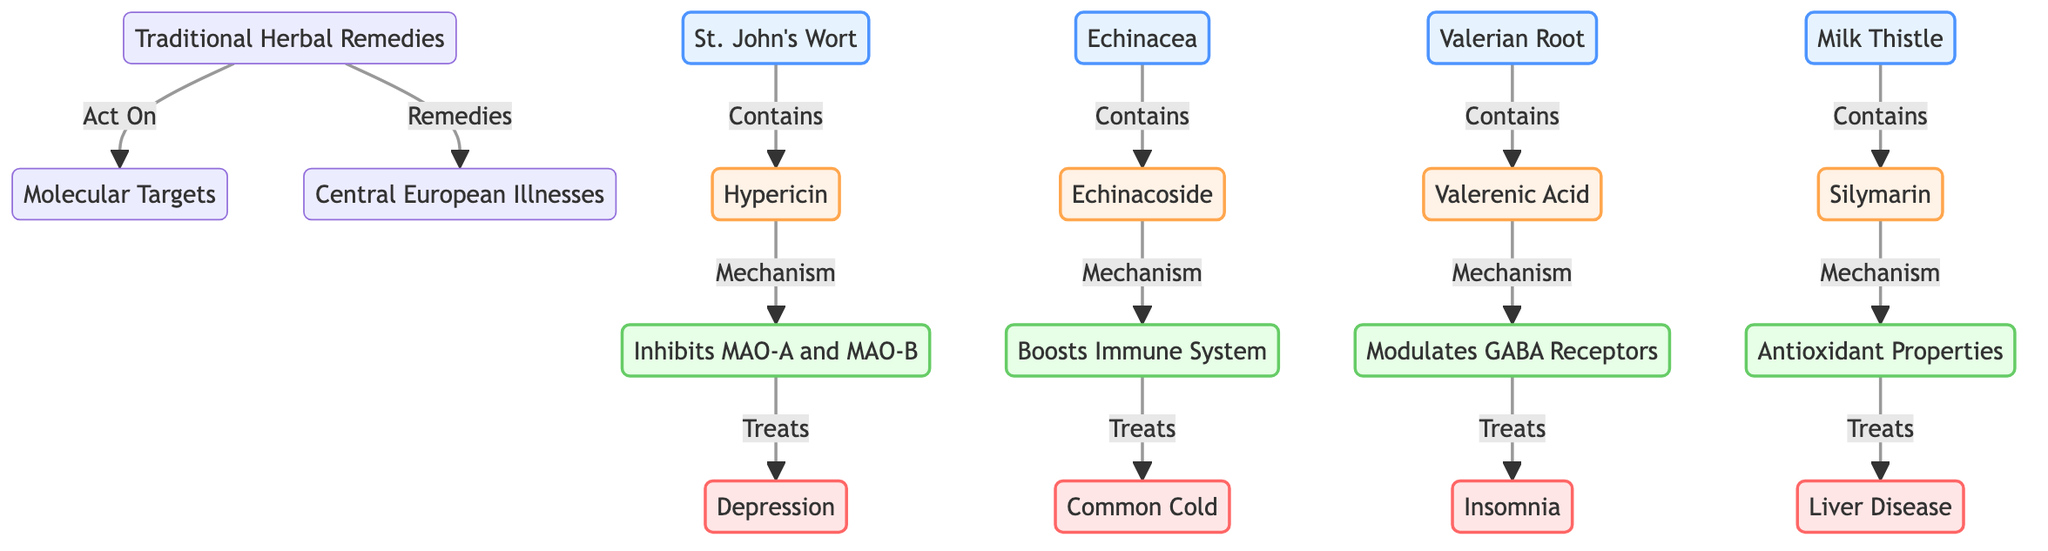What is the active ingredient in St. John's Wort? The diagram specifies that St. John's Wort contains Hypericin as its active ingredient.
Answer: Hypericin How many traditional herbal remedies are listed in the diagram? By counting the individual herbal remedies illustrated, there are four mentioned: St. John's Wort, Echinacea, Valerian Root, and Milk Thistle.
Answer: 4 What illness is associated with Echinacea? The diagram indicates that Echinacea is used to treat the Common Cold.
Answer: Common Cold Which herbal remedy is linked to insomnia? The diagram shows that Valerian Root is connected with the treatment of insomnia.
Answer: Valerian Root What mechanism does St. John's Wort utilize to treat depression? The flowchart reveals that St. John's Wort works by inhibiting MAO-A and MAO-B to address depression.
Answer: Inhibits MAO-A and MAO-B Name one molecular target that Echinacea acts upon. The diagram indicates that Echinacoside boosts the immune system, indicating its molecular effect.
Answer: Echinacoside Which illness does Milk Thistle combat according to the diagram? The flowchart informs that Milk Thistle targets Liver Disease as its associated ailment.
Answer: Liver Disease What is the active ingredient in Valerian Root? The diagram specifies that Valerian Root contains Valerenic Acid as its active component.
Answer: Valerenic Acid How does Valerian Root's mechanism function in relation to its illness? The diagram shows that Valerian Root modulates GABA receptors, which helps relieve insomnia.
Answer: Modulates GABA Receptors 